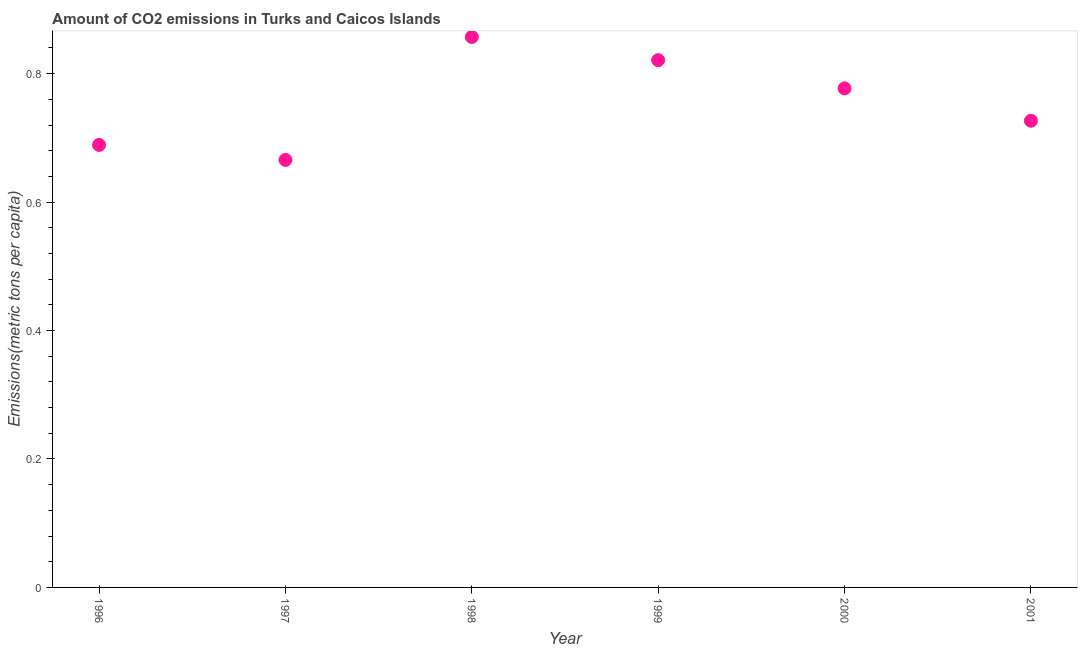What is the amount of co2 emissions in 1998?
Give a very brief answer. 0.86. Across all years, what is the maximum amount of co2 emissions?
Make the answer very short. 0.86. Across all years, what is the minimum amount of co2 emissions?
Keep it short and to the point. 0.67. In which year was the amount of co2 emissions maximum?
Make the answer very short. 1998. What is the sum of the amount of co2 emissions?
Keep it short and to the point. 4.54. What is the difference between the amount of co2 emissions in 1997 and 2000?
Give a very brief answer. -0.11. What is the average amount of co2 emissions per year?
Keep it short and to the point. 0.76. What is the median amount of co2 emissions?
Make the answer very short. 0.75. In how many years, is the amount of co2 emissions greater than 0.28 metric tons per capita?
Provide a short and direct response. 6. What is the ratio of the amount of co2 emissions in 1998 to that in 2000?
Ensure brevity in your answer.  1.1. Is the difference between the amount of co2 emissions in 1998 and 2000 greater than the difference between any two years?
Offer a terse response. No. What is the difference between the highest and the second highest amount of co2 emissions?
Provide a succinct answer. 0.04. What is the difference between the highest and the lowest amount of co2 emissions?
Offer a terse response. 0.19. In how many years, is the amount of co2 emissions greater than the average amount of co2 emissions taken over all years?
Your response must be concise. 3. Does the amount of co2 emissions monotonically increase over the years?
Keep it short and to the point. No. How many dotlines are there?
Your answer should be very brief. 1. What is the difference between two consecutive major ticks on the Y-axis?
Make the answer very short. 0.2. Does the graph contain any zero values?
Keep it short and to the point. No. Does the graph contain grids?
Your answer should be compact. No. What is the title of the graph?
Ensure brevity in your answer.  Amount of CO2 emissions in Turks and Caicos Islands. What is the label or title of the X-axis?
Give a very brief answer. Year. What is the label or title of the Y-axis?
Provide a succinct answer. Emissions(metric tons per capita). What is the Emissions(metric tons per capita) in 1996?
Keep it short and to the point. 0.69. What is the Emissions(metric tons per capita) in 1997?
Provide a short and direct response. 0.67. What is the Emissions(metric tons per capita) in 1998?
Provide a succinct answer. 0.86. What is the Emissions(metric tons per capita) in 1999?
Your answer should be very brief. 0.82. What is the Emissions(metric tons per capita) in 2000?
Keep it short and to the point. 0.78. What is the Emissions(metric tons per capita) in 2001?
Provide a succinct answer. 0.73. What is the difference between the Emissions(metric tons per capita) in 1996 and 1997?
Make the answer very short. 0.02. What is the difference between the Emissions(metric tons per capita) in 1996 and 1998?
Offer a very short reply. -0.17. What is the difference between the Emissions(metric tons per capita) in 1996 and 1999?
Ensure brevity in your answer.  -0.13. What is the difference between the Emissions(metric tons per capita) in 1996 and 2000?
Offer a very short reply. -0.09. What is the difference between the Emissions(metric tons per capita) in 1996 and 2001?
Your response must be concise. -0.04. What is the difference between the Emissions(metric tons per capita) in 1997 and 1998?
Offer a terse response. -0.19. What is the difference between the Emissions(metric tons per capita) in 1997 and 1999?
Offer a terse response. -0.16. What is the difference between the Emissions(metric tons per capita) in 1997 and 2000?
Offer a very short reply. -0.11. What is the difference between the Emissions(metric tons per capita) in 1997 and 2001?
Offer a terse response. -0.06. What is the difference between the Emissions(metric tons per capita) in 1998 and 1999?
Offer a terse response. 0.04. What is the difference between the Emissions(metric tons per capita) in 1998 and 2000?
Offer a terse response. 0.08. What is the difference between the Emissions(metric tons per capita) in 1998 and 2001?
Offer a very short reply. 0.13. What is the difference between the Emissions(metric tons per capita) in 1999 and 2000?
Offer a terse response. 0.04. What is the difference between the Emissions(metric tons per capita) in 1999 and 2001?
Give a very brief answer. 0.09. What is the difference between the Emissions(metric tons per capita) in 2000 and 2001?
Make the answer very short. 0.05. What is the ratio of the Emissions(metric tons per capita) in 1996 to that in 1997?
Provide a short and direct response. 1.03. What is the ratio of the Emissions(metric tons per capita) in 1996 to that in 1998?
Offer a terse response. 0.8. What is the ratio of the Emissions(metric tons per capita) in 1996 to that in 1999?
Offer a terse response. 0.84. What is the ratio of the Emissions(metric tons per capita) in 1996 to that in 2000?
Provide a short and direct response. 0.89. What is the ratio of the Emissions(metric tons per capita) in 1996 to that in 2001?
Provide a short and direct response. 0.95. What is the ratio of the Emissions(metric tons per capita) in 1997 to that in 1998?
Provide a short and direct response. 0.78. What is the ratio of the Emissions(metric tons per capita) in 1997 to that in 1999?
Your answer should be very brief. 0.81. What is the ratio of the Emissions(metric tons per capita) in 1997 to that in 2000?
Provide a short and direct response. 0.86. What is the ratio of the Emissions(metric tons per capita) in 1997 to that in 2001?
Offer a terse response. 0.92. What is the ratio of the Emissions(metric tons per capita) in 1998 to that in 1999?
Provide a short and direct response. 1.04. What is the ratio of the Emissions(metric tons per capita) in 1998 to that in 2000?
Offer a terse response. 1.1. What is the ratio of the Emissions(metric tons per capita) in 1998 to that in 2001?
Provide a short and direct response. 1.18. What is the ratio of the Emissions(metric tons per capita) in 1999 to that in 2000?
Offer a terse response. 1.06. What is the ratio of the Emissions(metric tons per capita) in 1999 to that in 2001?
Give a very brief answer. 1.13. What is the ratio of the Emissions(metric tons per capita) in 2000 to that in 2001?
Make the answer very short. 1.07. 